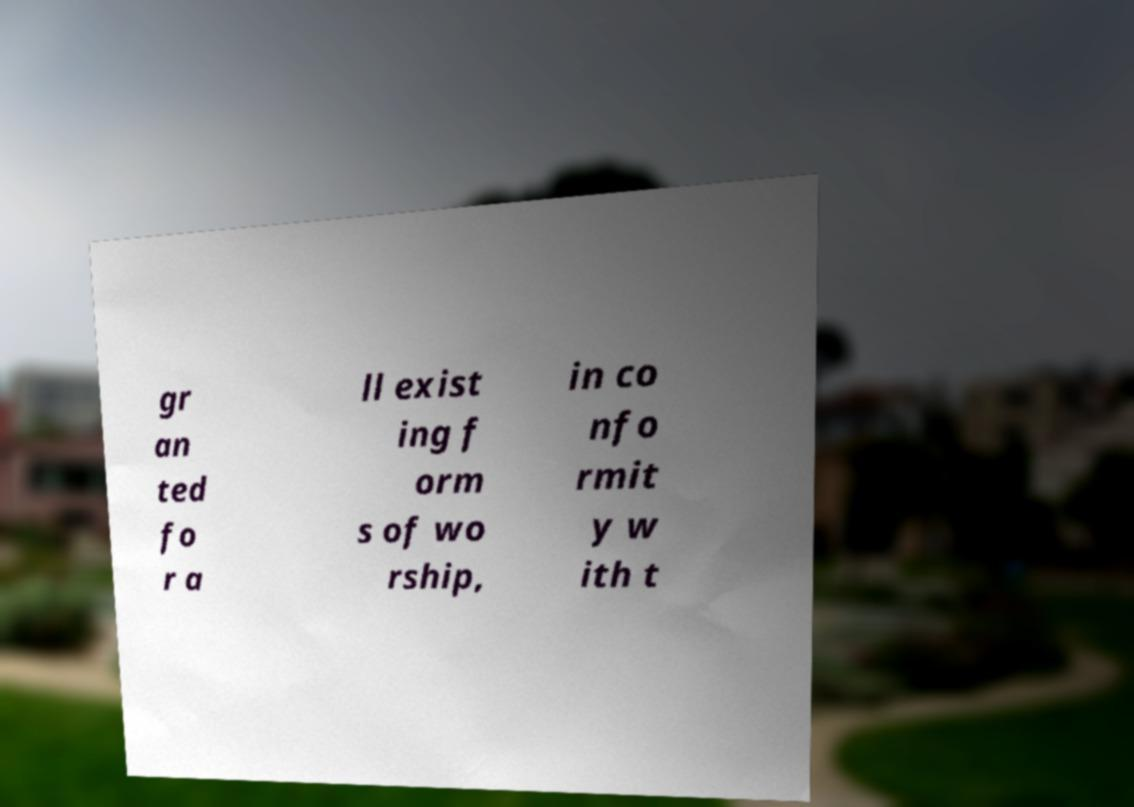Please read and relay the text visible in this image. What does it say? gr an ted fo r a ll exist ing f orm s of wo rship, in co nfo rmit y w ith t 